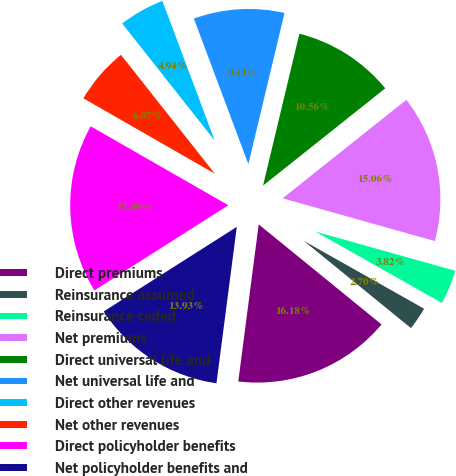<chart> <loc_0><loc_0><loc_500><loc_500><pie_chart><fcel>Direct premiums<fcel>Reinsurance assumed<fcel>Reinsurance ceded<fcel>Net premiums<fcel>Direct universal life and<fcel>Net universal life and<fcel>Direct other revenues<fcel>Net other revenues<fcel>Direct policyholder benefits<fcel>Net policyholder benefits and<nl><fcel>16.18%<fcel>2.7%<fcel>3.82%<fcel>15.06%<fcel>10.56%<fcel>9.44%<fcel>4.94%<fcel>6.07%<fcel>17.3%<fcel>13.93%<nl></chart> 